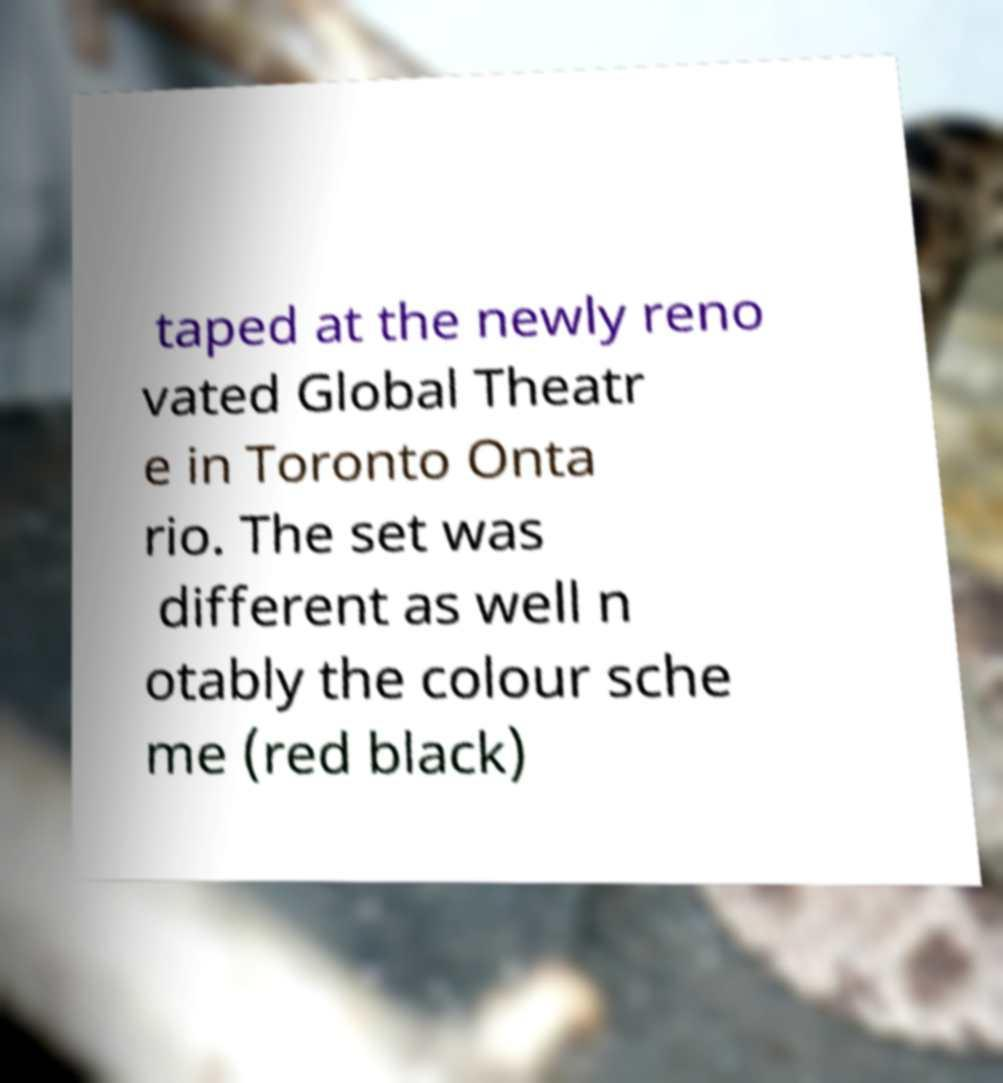Can you accurately transcribe the text from the provided image for me? taped at the newly reno vated Global Theatr e in Toronto Onta rio. The set was different as well n otably the colour sche me (red black) 